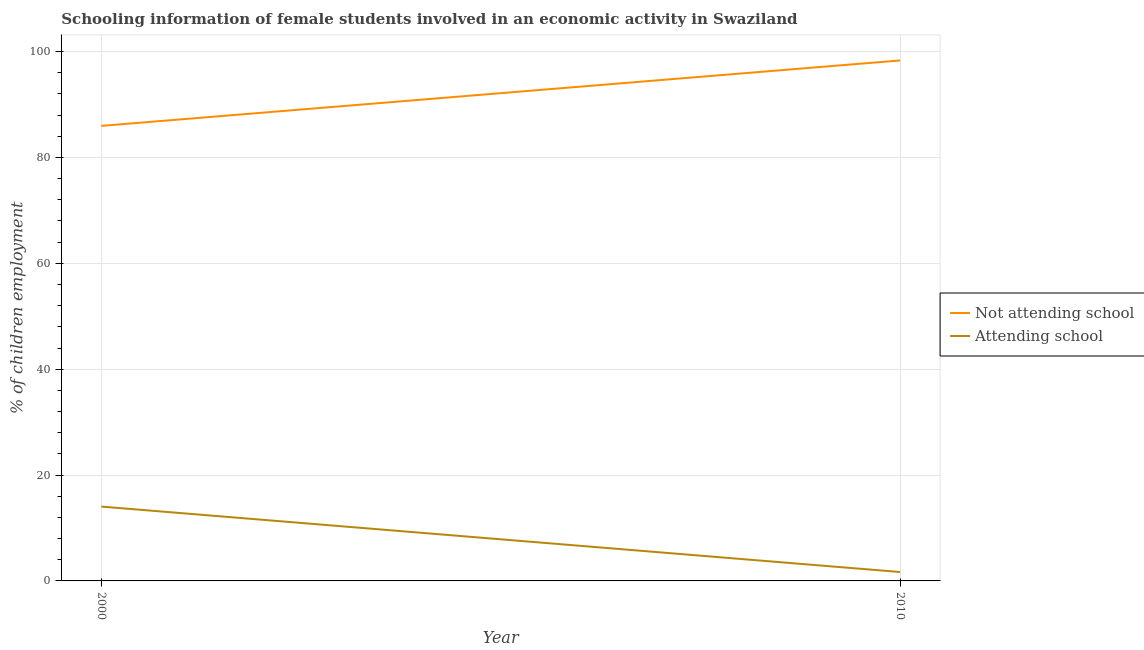What is the percentage of employed females who are not attending school in 2000?
Your answer should be very brief. 85.96. Across all years, what is the maximum percentage of employed females who are attending school?
Ensure brevity in your answer.  14.04. Across all years, what is the minimum percentage of employed females who are not attending school?
Offer a terse response. 85.96. In which year was the percentage of employed females who are not attending school maximum?
Make the answer very short. 2010. What is the total percentage of employed females who are not attending school in the graph?
Provide a short and direct response. 184.28. What is the difference between the percentage of employed females who are not attending school in 2000 and that in 2010?
Your answer should be very brief. -12.36. What is the difference between the percentage of employed females who are not attending school in 2010 and the percentage of employed females who are attending school in 2000?
Provide a short and direct response. 84.28. What is the average percentage of employed females who are not attending school per year?
Provide a succinct answer. 92.14. In the year 2000, what is the difference between the percentage of employed females who are not attending school and percentage of employed females who are attending school?
Provide a short and direct response. 71.92. In how many years, is the percentage of employed females who are not attending school greater than 96 %?
Keep it short and to the point. 1. What is the ratio of the percentage of employed females who are attending school in 2000 to that in 2010?
Your response must be concise. 8.36. Does the percentage of employed females who are not attending school monotonically increase over the years?
Your answer should be compact. Yes. Is the percentage of employed females who are not attending school strictly less than the percentage of employed females who are attending school over the years?
Offer a terse response. No. How many lines are there?
Keep it short and to the point. 2. What is the difference between two consecutive major ticks on the Y-axis?
Your answer should be very brief. 20. Does the graph contain any zero values?
Make the answer very short. No. Does the graph contain grids?
Provide a succinct answer. Yes. Where does the legend appear in the graph?
Make the answer very short. Center right. How are the legend labels stacked?
Offer a terse response. Vertical. What is the title of the graph?
Offer a very short reply. Schooling information of female students involved in an economic activity in Swaziland. What is the label or title of the X-axis?
Give a very brief answer. Year. What is the label or title of the Y-axis?
Provide a short and direct response. % of children employment. What is the % of children employment of Not attending school in 2000?
Your answer should be very brief. 85.96. What is the % of children employment of Attending school in 2000?
Your answer should be very brief. 14.04. What is the % of children employment of Not attending school in 2010?
Your response must be concise. 98.32. What is the % of children employment of Attending school in 2010?
Your answer should be compact. 1.68. Across all years, what is the maximum % of children employment in Not attending school?
Keep it short and to the point. 98.32. Across all years, what is the maximum % of children employment in Attending school?
Give a very brief answer. 14.04. Across all years, what is the minimum % of children employment of Not attending school?
Offer a terse response. 85.96. Across all years, what is the minimum % of children employment of Attending school?
Your response must be concise. 1.68. What is the total % of children employment in Not attending school in the graph?
Your answer should be compact. 184.28. What is the total % of children employment of Attending school in the graph?
Keep it short and to the point. 15.72. What is the difference between the % of children employment of Not attending school in 2000 and that in 2010?
Provide a short and direct response. -12.36. What is the difference between the % of children employment of Attending school in 2000 and that in 2010?
Your answer should be compact. 12.36. What is the difference between the % of children employment in Not attending school in 2000 and the % of children employment in Attending school in 2010?
Your answer should be very brief. 84.28. What is the average % of children employment in Not attending school per year?
Your response must be concise. 92.14. What is the average % of children employment of Attending school per year?
Provide a short and direct response. 7.86. In the year 2000, what is the difference between the % of children employment of Not attending school and % of children employment of Attending school?
Provide a succinct answer. 71.92. In the year 2010, what is the difference between the % of children employment of Not attending school and % of children employment of Attending school?
Give a very brief answer. 96.64. What is the ratio of the % of children employment in Not attending school in 2000 to that in 2010?
Provide a short and direct response. 0.87. What is the ratio of the % of children employment in Attending school in 2000 to that in 2010?
Your answer should be very brief. 8.36. What is the difference between the highest and the second highest % of children employment of Not attending school?
Give a very brief answer. 12.36. What is the difference between the highest and the second highest % of children employment of Attending school?
Offer a terse response. 12.36. What is the difference between the highest and the lowest % of children employment in Not attending school?
Keep it short and to the point. 12.36. What is the difference between the highest and the lowest % of children employment in Attending school?
Give a very brief answer. 12.36. 